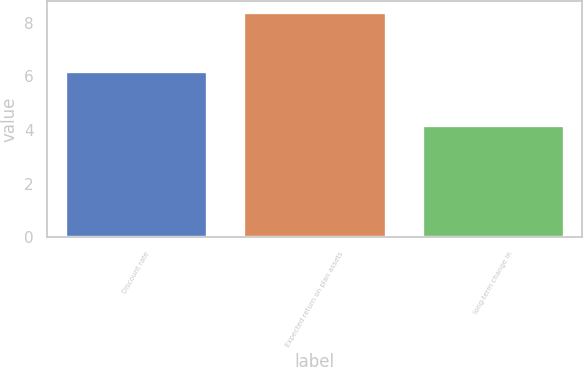<chart> <loc_0><loc_0><loc_500><loc_500><bar_chart><fcel>Discount rate<fcel>Expected return on plan assets<fcel>long-term change in<nl><fcel>6.2<fcel>8.4<fcel>4.2<nl></chart> 